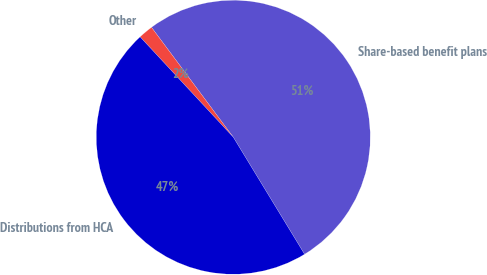<chart> <loc_0><loc_0><loc_500><loc_500><pie_chart><fcel>Share-based benefit plans<fcel>Other<fcel>Distributions from HCA<nl><fcel>51.48%<fcel>1.73%<fcel>46.8%<nl></chart> 